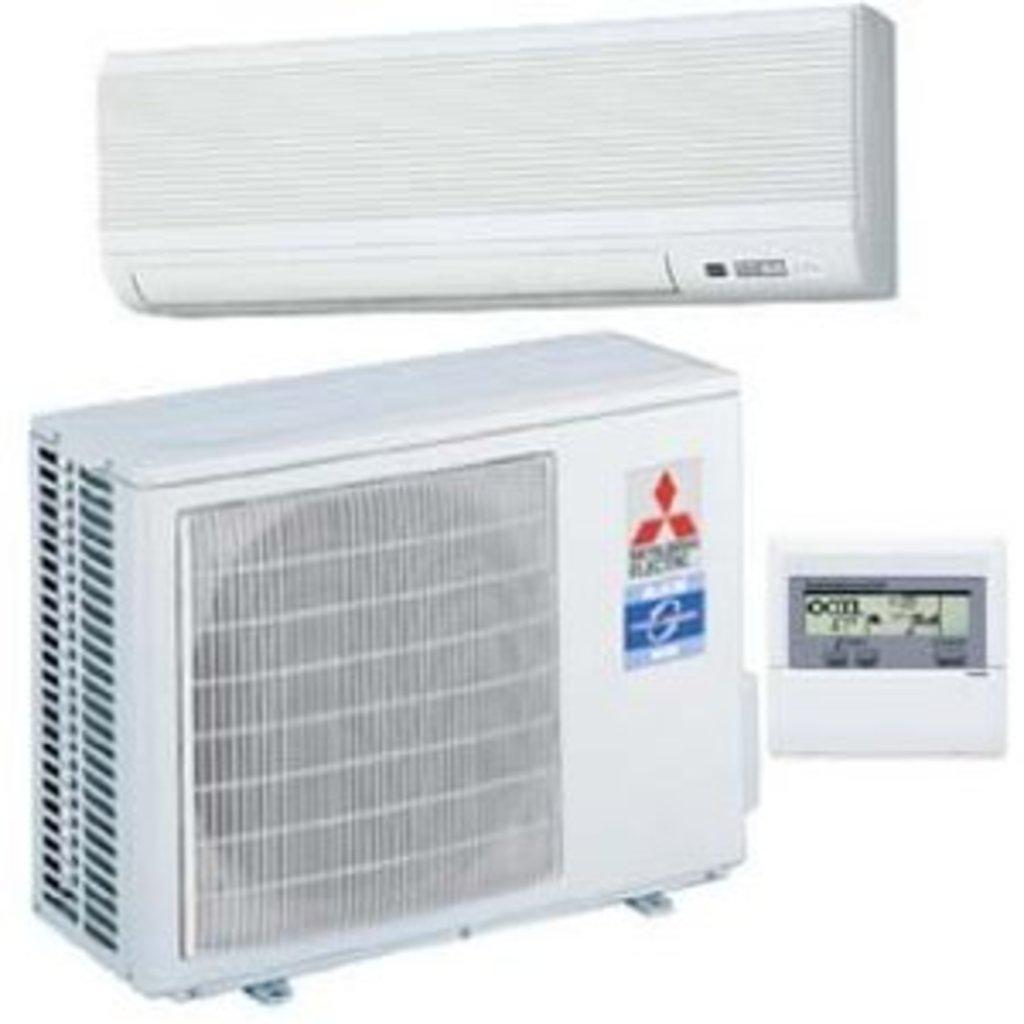Please provide a concise description of this image. In this image I can see few white colour electronic devices. I can also see few logos over here. 